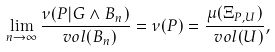<formula> <loc_0><loc_0><loc_500><loc_500>\lim _ { n \to \infty } \frac { \nu ( P | G \wedge B _ { n } ) } { \ v o l ( B _ { n } ) } = \nu ( P ) = \frac { \mu ( \Xi _ { P , U } ) } { \ v o l ( U ) } ,</formula> 